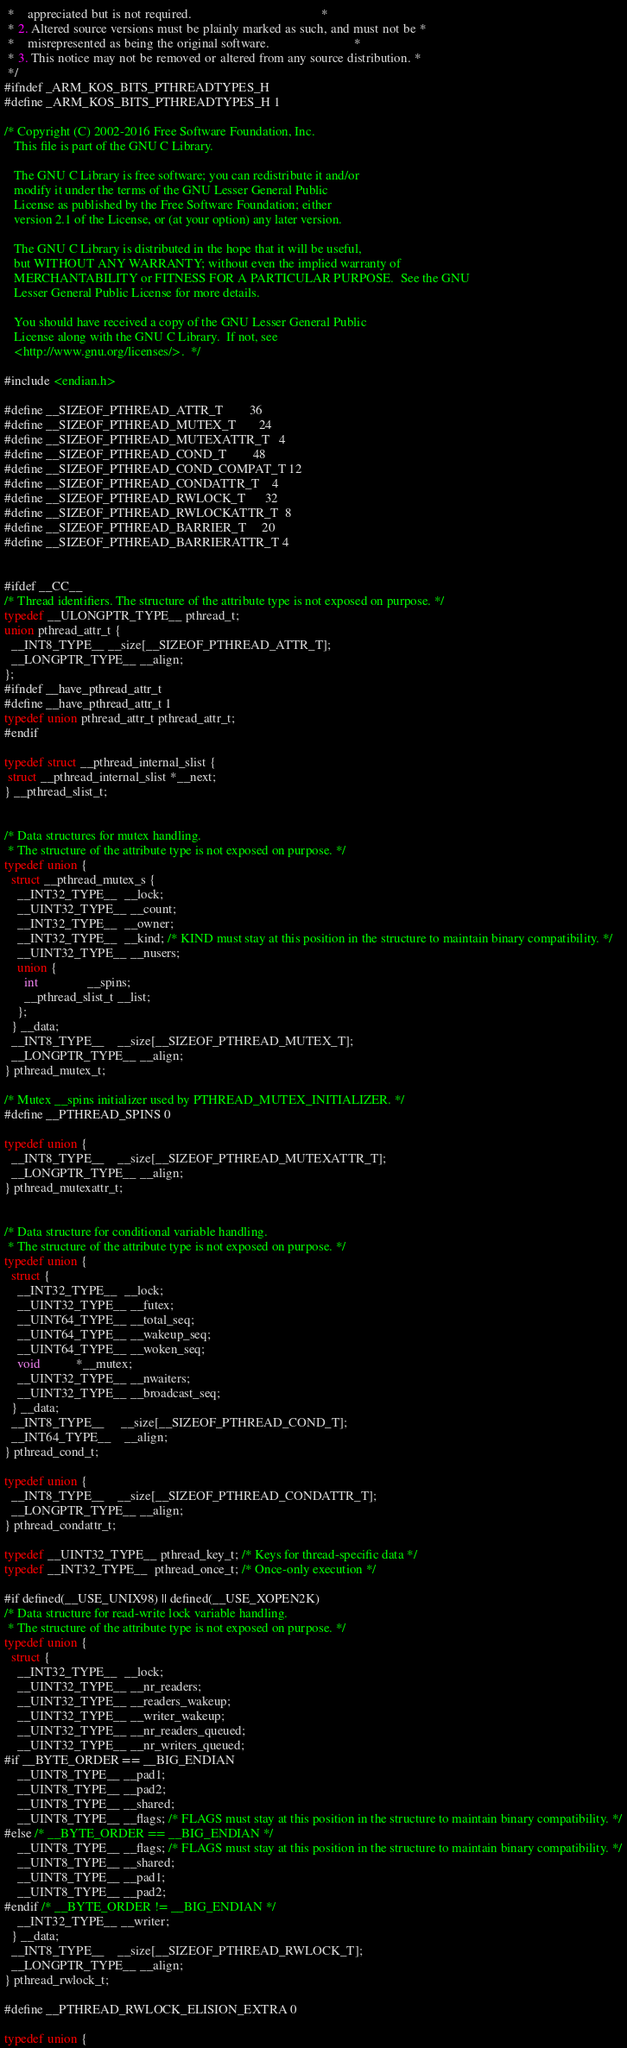Convert code to text. <code><loc_0><loc_0><loc_500><loc_500><_C_> *    appreciated but is not required.                                        *
 * 2. Altered source versions must be plainly marked as such, and must not be *
 *    misrepresented as being the original software.                          *
 * 3. This notice may not be removed or altered from any source distribution. *
 */
#ifndef _ARM_KOS_BITS_PTHREADTYPES_H
#define _ARM_KOS_BITS_PTHREADTYPES_H 1

/* Copyright (C) 2002-2016 Free Software Foundation, Inc.
   This file is part of the GNU C Library.

   The GNU C Library is free software; you can redistribute it and/or
   modify it under the terms of the GNU Lesser General Public
   License as published by the Free Software Foundation; either
   version 2.1 of the License, or (at your option) any later version.

   The GNU C Library is distributed in the hope that it will be useful,
   but WITHOUT ANY WARRANTY; without even the implied warranty of
   MERCHANTABILITY or FITNESS FOR A PARTICULAR PURPOSE.  See the GNU
   Lesser General Public License for more details.

   You should have received a copy of the GNU Lesser General Public
   License along with the GNU C Library.  If not, see
   <http://www.gnu.org/licenses/>.  */

#include <endian.h>

#define __SIZEOF_PTHREAD_ATTR_T        36
#define __SIZEOF_PTHREAD_MUTEX_T       24
#define __SIZEOF_PTHREAD_MUTEXATTR_T   4
#define __SIZEOF_PTHREAD_COND_T        48
#define __SIZEOF_PTHREAD_COND_COMPAT_T 12
#define __SIZEOF_PTHREAD_CONDATTR_T    4
#define __SIZEOF_PTHREAD_RWLOCK_T      32
#define __SIZEOF_PTHREAD_RWLOCKATTR_T  8
#define __SIZEOF_PTHREAD_BARRIER_T     20
#define __SIZEOF_PTHREAD_BARRIERATTR_T 4


#ifdef __CC__
/* Thread identifiers. The structure of the attribute type is not exposed on purpose. */
typedef __ULONGPTR_TYPE__ pthread_t;
union pthread_attr_t {
  __INT8_TYPE__ __size[__SIZEOF_PTHREAD_ATTR_T];
  __LONGPTR_TYPE__ __align;
};
#ifndef __have_pthread_attr_t
#define __have_pthread_attr_t 1
typedef union pthread_attr_t pthread_attr_t;
#endif

typedef struct __pthread_internal_slist {
 struct __pthread_internal_slist *__next;
} __pthread_slist_t;


/* Data structures for mutex handling.
 * The structure of the attribute type is not exposed on purpose. */
typedef union {
  struct __pthread_mutex_s {
    __INT32_TYPE__  __lock;
    __UINT32_TYPE__ __count;
    __INT32_TYPE__  __owner;
    __INT32_TYPE__  __kind; /* KIND must stay at this position in the structure to maintain binary compatibility. */
    __UINT32_TYPE__ __nusers;
    union {
      int               __spins;
      __pthread_slist_t __list;
    };
  } __data;
  __INT8_TYPE__    __size[__SIZEOF_PTHREAD_MUTEX_T];
  __LONGPTR_TYPE__ __align;
} pthread_mutex_t;

/* Mutex __spins initializer used by PTHREAD_MUTEX_INITIALIZER. */
#define __PTHREAD_SPINS 0

typedef union {
  __INT8_TYPE__    __size[__SIZEOF_PTHREAD_MUTEXATTR_T];
  __LONGPTR_TYPE__ __align;
} pthread_mutexattr_t;


/* Data structure for conditional variable handling.
 * The structure of the attribute type is not exposed on purpose. */
typedef union {
  struct {
    __INT32_TYPE__  __lock;
    __UINT32_TYPE__ __futex;
    __UINT64_TYPE__ __total_seq;
    __UINT64_TYPE__ __wakeup_seq;
    __UINT64_TYPE__ __woken_seq;
    void           *__mutex;
    __UINT32_TYPE__ __nwaiters;
    __UINT32_TYPE__ __broadcast_seq;
  } __data;
  __INT8_TYPE__     __size[__SIZEOF_PTHREAD_COND_T];
  __INT64_TYPE__    __align;
} pthread_cond_t;

typedef union {
  __INT8_TYPE__    __size[__SIZEOF_PTHREAD_CONDATTR_T];
  __LONGPTR_TYPE__ __align;
} pthread_condattr_t;

typedef __UINT32_TYPE__ pthread_key_t; /* Keys for thread-specific data */
typedef __INT32_TYPE__  pthread_once_t; /* Once-only execution */

#if defined(__USE_UNIX98) || defined(__USE_XOPEN2K)
/* Data structure for read-write lock variable handling.
 * The structure of the attribute type is not exposed on purpose. */
typedef union {
  struct {
    __INT32_TYPE__  __lock;
    __UINT32_TYPE__ __nr_readers;
    __UINT32_TYPE__ __readers_wakeup;
    __UINT32_TYPE__ __writer_wakeup;
    __UINT32_TYPE__ __nr_readers_queued;
    __UINT32_TYPE__ __nr_writers_queued;
#if __BYTE_ORDER == __BIG_ENDIAN
    __UINT8_TYPE__ __pad1;
    __UINT8_TYPE__ __pad2;
    __UINT8_TYPE__ __shared;
    __UINT8_TYPE__ __flags; /* FLAGS must stay at this position in the structure to maintain binary compatibility. */
#else /* __BYTE_ORDER == __BIG_ENDIAN */
    __UINT8_TYPE__ __flags; /* FLAGS must stay at this position in the structure to maintain binary compatibility. */
    __UINT8_TYPE__ __shared;
    __UINT8_TYPE__ __pad1;
    __UINT8_TYPE__ __pad2;
#endif /* __BYTE_ORDER != __BIG_ENDIAN */
    __INT32_TYPE__ __writer;
  } __data;
  __INT8_TYPE__    __size[__SIZEOF_PTHREAD_RWLOCK_T];
  __LONGPTR_TYPE__ __align;
} pthread_rwlock_t;

#define __PTHREAD_RWLOCK_ELISION_EXTRA 0

typedef union {</code> 